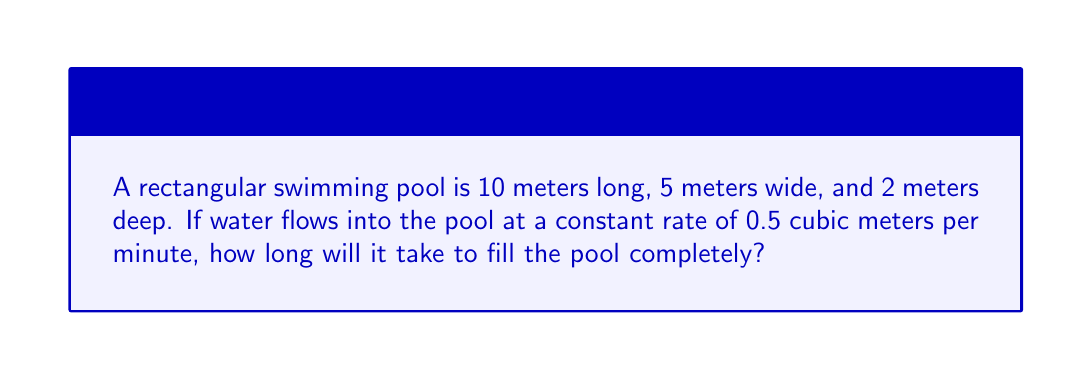Show me your answer to this math problem. Let's solve this problem step by step:

1. Calculate the volume of the pool:
   $$ \text{Volume} = \text{Length} \times \text{Width} \times \text{Depth} $$
   $$ \text{Volume} = 10 \text{ m} \times 5 \text{ m} \times 2 \text{ m} = 100 \text{ m}^3 $$

2. Understand the rate at which the pool is being filled:
   The pool is being filled at a rate of 0.5 cubic meters per minute.

3. Set up the equation:
   $$ \text{Time} = \frac{\text{Volume}}{\text{Rate}} $$

4. Plug in the values:
   $$ \text{Time} = \frac{100 \text{ m}^3}{0.5 \text{ m}^3/\text{min}} $$

5. Solve for time:
   $$ \text{Time} = 200 \text{ minutes} $$

6. Convert minutes to hours (optional):
   $$ 200 \text{ minutes} = \frac{200}{60} \text{ hours} = 3 \frac{1}{3} \text{ hours} $$

Therefore, it will take 200 minutes or 3 hours and 20 minutes to fill the pool completely.
Answer: 200 minutes 